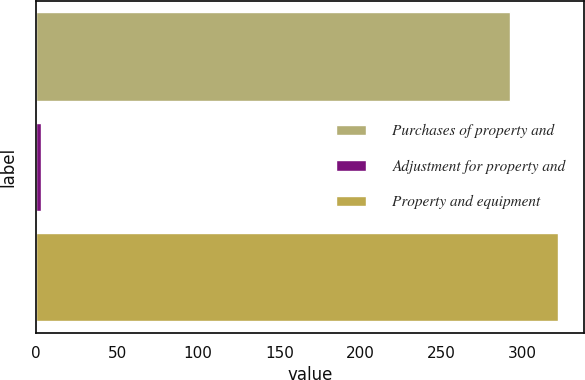Convert chart to OTSL. <chart><loc_0><loc_0><loc_500><loc_500><bar_chart><fcel>Purchases of property and<fcel>Adjustment for property and<fcel>Property and equipment<nl><fcel>292.5<fcel>3.2<fcel>321.75<nl></chart> 